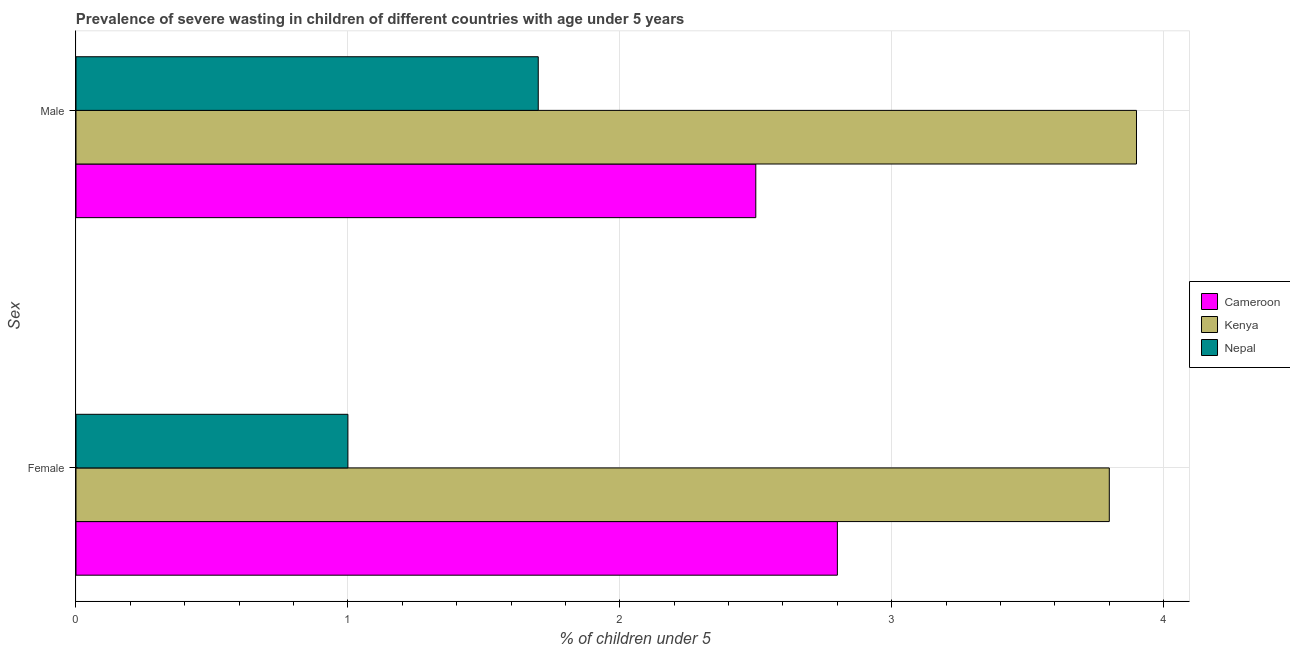Are the number of bars on each tick of the Y-axis equal?
Provide a succinct answer. Yes. How many bars are there on the 2nd tick from the top?
Make the answer very short. 3. How many bars are there on the 1st tick from the bottom?
Offer a very short reply. 3. What is the label of the 2nd group of bars from the top?
Ensure brevity in your answer.  Female. What is the percentage of undernourished female children in Nepal?
Offer a very short reply. 1. Across all countries, what is the maximum percentage of undernourished female children?
Provide a short and direct response. 3.8. In which country was the percentage of undernourished male children maximum?
Your answer should be compact. Kenya. In which country was the percentage of undernourished female children minimum?
Provide a succinct answer. Nepal. What is the total percentage of undernourished female children in the graph?
Ensure brevity in your answer.  7.6. What is the difference between the percentage of undernourished male children in Nepal and that in Kenya?
Offer a terse response. -2.2. What is the difference between the percentage of undernourished male children in Nepal and the percentage of undernourished female children in Kenya?
Provide a succinct answer. -2.1. What is the average percentage of undernourished female children per country?
Provide a short and direct response. 2.53. What is the difference between the percentage of undernourished female children and percentage of undernourished male children in Kenya?
Provide a succinct answer. -0.1. In how many countries, is the percentage of undernourished male children greater than 1.2 %?
Provide a short and direct response. 3. What is the ratio of the percentage of undernourished male children in Cameroon to that in Kenya?
Keep it short and to the point. 0.64. Is the percentage of undernourished female children in Cameroon less than that in Nepal?
Keep it short and to the point. No. What does the 3rd bar from the top in Female represents?
Give a very brief answer. Cameroon. What does the 3rd bar from the bottom in Male represents?
Keep it short and to the point. Nepal. How many bars are there?
Offer a terse response. 6. Are the values on the major ticks of X-axis written in scientific E-notation?
Your answer should be very brief. No. Does the graph contain any zero values?
Give a very brief answer. No. How are the legend labels stacked?
Your answer should be very brief. Vertical. What is the title of the graph?
Your answer should be very brief. Prevalence of severe wasting in children of different countries with age under 5 years. What is the label or title of the X-axis?
Offer a terse response.  % of children under 5. What is the label or title of the Y-axis?
Offer a very short reply. Sex. What is the  % of children under 5 in Cameroon in Female?
Offer a terse response. 2.8. What is the  % of children under 5 in Kenya in Female?
Give a very brief answer. 3.8. What is the  % of children under 5 of Nepal in Female?
Offer a very short reply. 1. What is the  % of children under 5 in Cameroon in Male?
Offer a terse response. 2.5. What is the  % of children under 5 in Kenya in Male?
Ensure brevity in your answer.  3.9. What is the  % of children under 5 of Nepal in Male?
Ensure brevity in your answer.  1.7. Across all Sex, what is the maximum  % of children under 5 in Cameroon?
Your answer should be compact. 2.8. Across all Sex, what is the maximum  % of children under 5 of Kenya?
Provide a short and direct response. 3.9. Across all Sex, what is the maximum  % of children under 5 of Nepal?
Provide a succinct answer. 1.7. Across all Sex, what is the minimum  % of children under 5 in Kenya?
Offer a very short reply. 3.8. Across all Sex, what is the minimum  % of children under 5 of Nepal?
Give a very brief answer. 1. What is the total  % of children under 5 in Nepal in the graph?
Make the answer very short. 2.7. What is the difference between the  % of children under 5 of Cameroon in Female and that in Male?
Offer a terse response. 0.3. What is the difference between the  % of children under 5 in Nepal in Female and that in Male?
Provide a short and direct response. -0.7. What is the difference between the  % of children under 5 of Cameroon in Female and the  % of children under 5 of Nepal in Male?
Make the answer very short. 1.1. What is the average  % of children under 5 of Cameroon per Sex?
Provide a succinct answer. 2.65. What is the average  % of children under 5 of Kenya per Sex?
Provide a succinct answer. 3.85. What is the average  % of children under 5 in Nepal per Sex?
Your answer should be very brief. 1.35. What is the difference between the  % of children under 5 of Cameroon and  % of children under 5 of Nepal in Female?
Your answer should be compact. 1.8. What is the difference between the  % of children under 5 in Cameroon and  % of children under 5 in Kenya in Male?
Provide a succinct answer. -1.4. What is the difference between the  % of children under 5 of Kenya and  % of children under 5 of Nepal in Male?
Your answer should be compact. 2.2. What is the ratio of the  % of children under 5 of Cameroon in Female to that in Male?
Offer a terse response. 1.12. What is the ratio of the  % of children under 5 of Kenya in Female to that in Male?
Ensure brevity in your answer.  0.97. What is the ratio of the  % of children under 5 in Nepal in Female to that in Male?
Ensure brevity in your answer.  0.59. What is the difference between the highest and the second highest  % of children under 5 of Cameroon?
Offer a terse response. 0.3. What is the difference between the highest and the second highest  % of children under 5 of Kenya?
Provide a succinct answer. 0.1. What is the difference between the highest and the second highest  % of children under 5 of Nepal?
Your response must be concise. 0.7. 